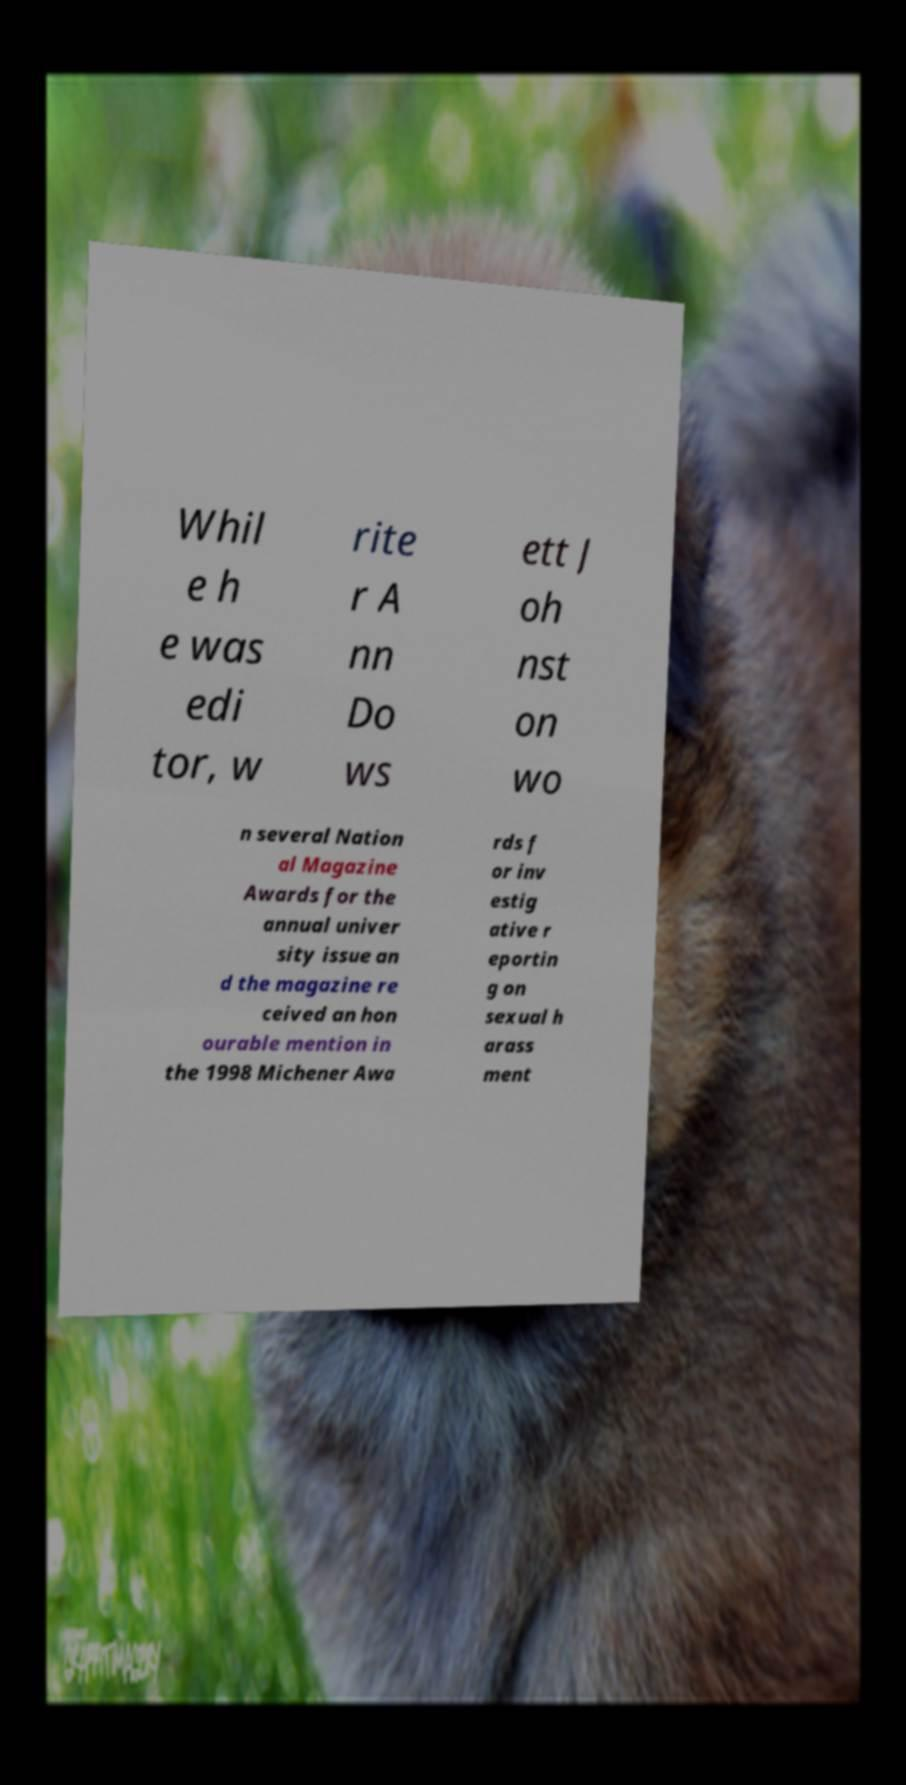What messages or text are displayed in this image? I need them in a readable, typed format. Whil e h e was edi tor, w rite r A nn Do ws ett J oh nst on wo n several Nation al Magazine Awards for the annual univer sity issue an d the magazine re ceived an hon ourable mention in the 1998 Michener Awa rds f or inv estig ative r eportin g on sexual h arass ment 